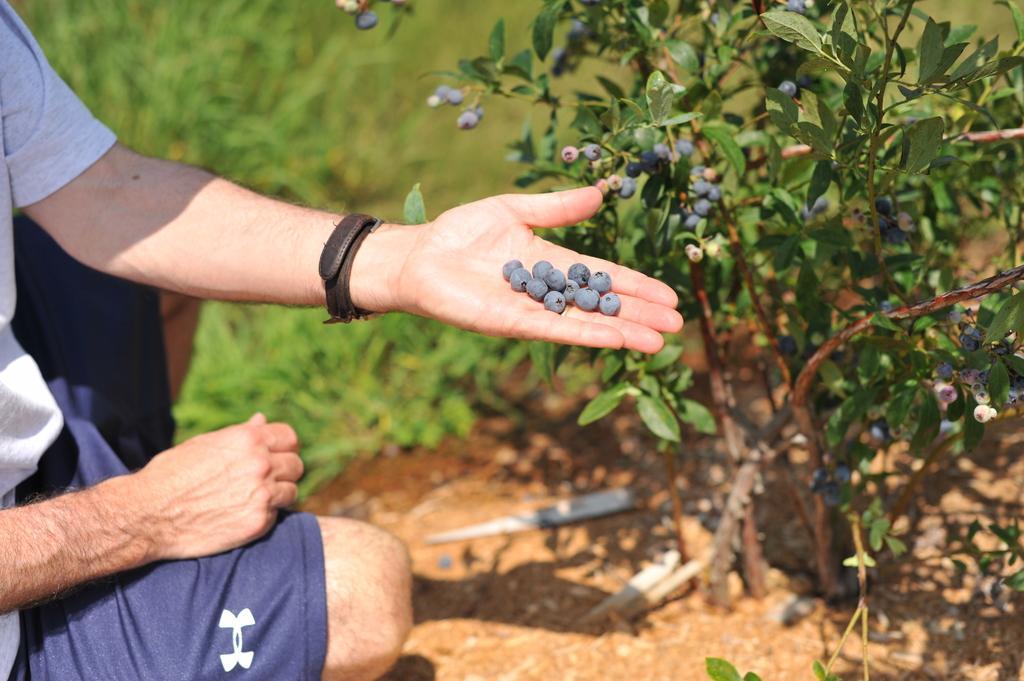In one or two sentences, can you explain what this image depicts? In this image we can see a person wearing ash color T-shirt and blue color short crouching down and there are some things in his hands and at the background of the image there are some plants and grass. 